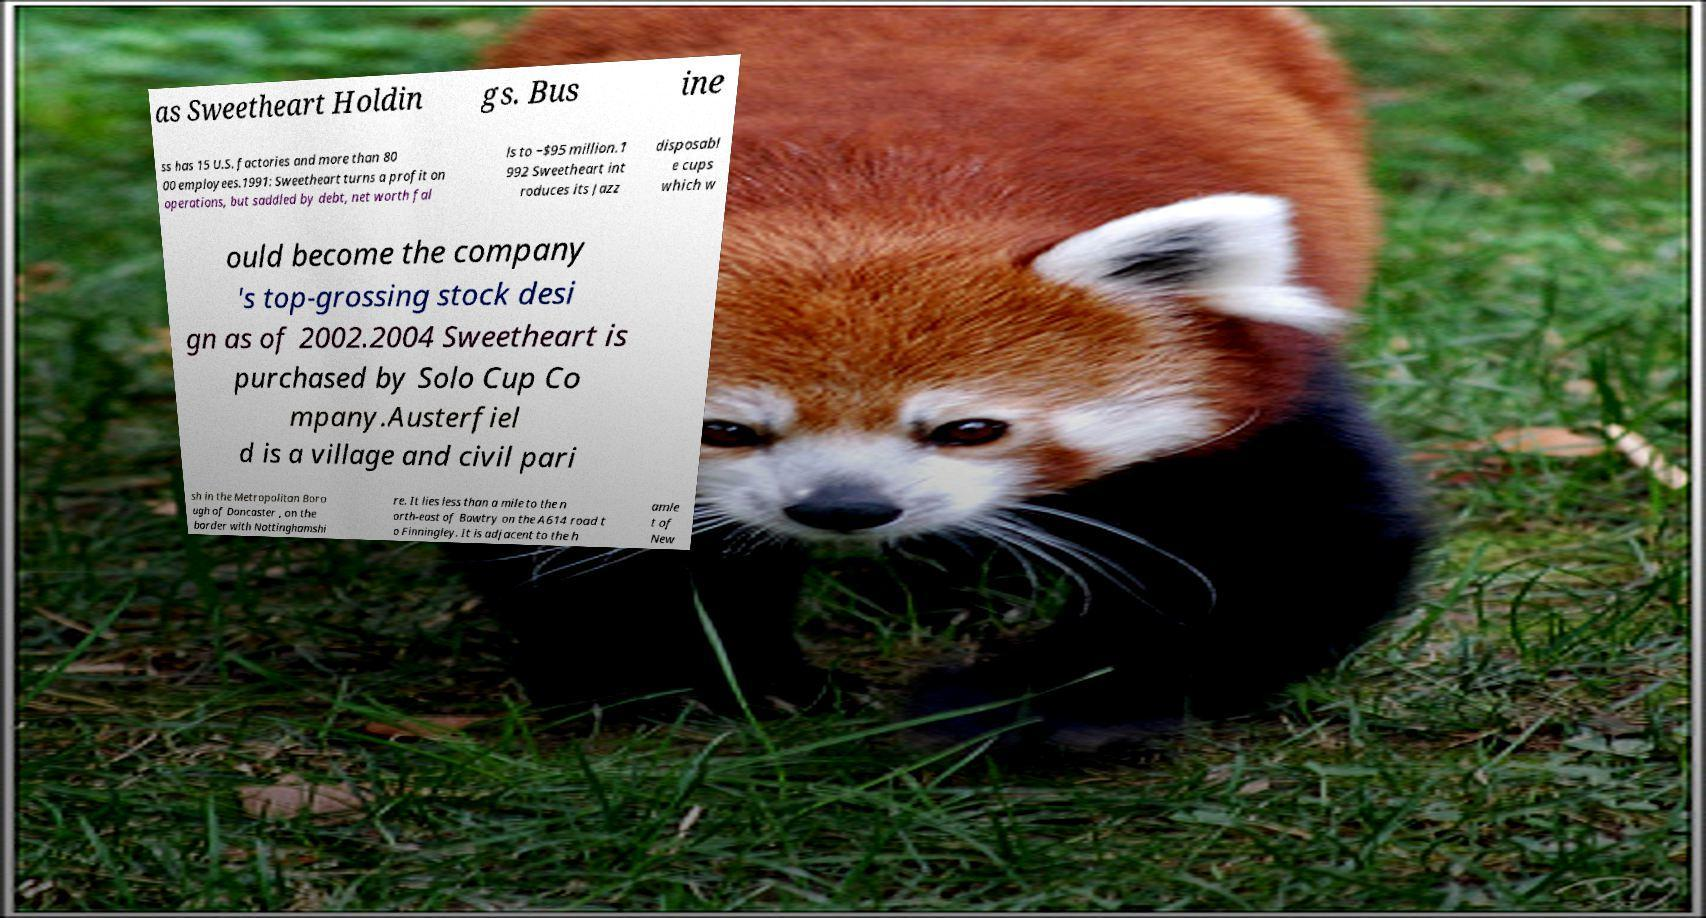Please read and relay the text visible in this image. What does it say? as Sweetheart Holdin gs. Bus ine ss has 15 U.S. factories and more than 80 00 employees.1991: Sweetheart turns a profit on operations, but saddled by debt, net worth fal ls to −$95 million.1 992 Sweetheart int roduces its Jazz disposabl e cups which w ould become the company 's top-grossing stock desi gn as of 2002.2004 Sweetheart is purchased by Solo Cup Co mpany.Austerfiel d is a village and civil pari sh in the Metropolitan Boro ugh of Doncaster , on the border with Nottinghamshi re. It lies less than a mile to the n orth-east of Bawtry on the A614 road t o Finningley. It is adjacent to the h amle t of New 